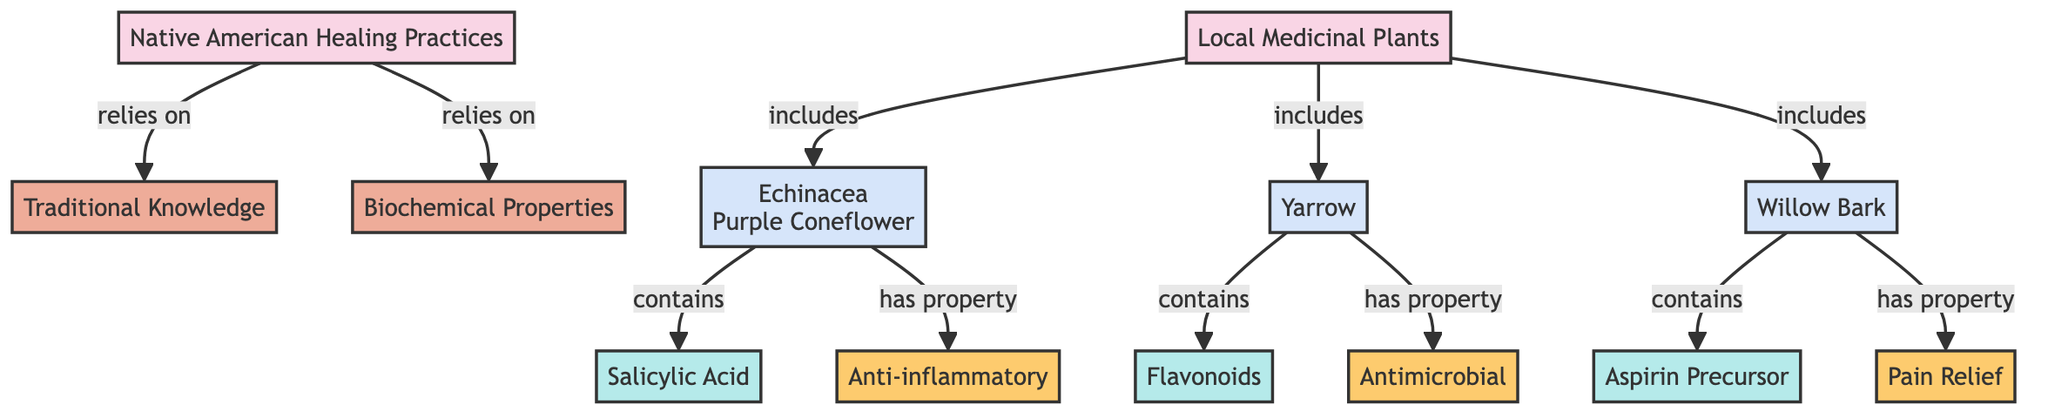What types of plants are included in local medicinal plants? The diagram lists three plants: Echinacea (Purple Coneflower), Yarrow, and Willow Bark, which fall under the category of local medicinal plants.
Answer: Echinacea, Yarrow, Willow Bark How many biochemical properties are mentioned in the diagram? The diagram presents three distinct biochemical properties: Anti-inflammatory, Antimicrobial, and Pain Relief, indicating a total of three unique properties.
Answer: 3 Which plant is associated with the property "Anti-inflammatory"? Echinacea (Purple Coneflower) is linked to the property of being anti-inflammatory, as indicated in the diagram's connections.
Answer: Echinacea (Purple Coneflower) What compound does Yarrow contain? According to the diagram, Yarrow contains Flavonoids, which are an important natural compound relevant to its healing properties.
Answer: Flavonoids What healing practice relies on traditional knowledge? The diagram indicates that Native American Healing Practices relies on traditional knowledge, signifying the importance of cultural heritage in these practices.
Answer: Traditional Knowledge What is the role of Willow Bark in local medicinal practices? Willow Bark serves as a source of Aspirin Precursor, which is vital for its application in pain relief, demonstrating its significance in traditional medicine.
Answer: Aspirin Precursor Which plant is mentioned as containing salicylic acid? The diagram specifies that Echinacea (Purple Coneflower) contains salicylic acid, highlighting its biochemical relevance in healing practices.
Answer: Salicylic Acid What relationship do Native American Healing Practices have with local medicinal plants? The diagram shows that Native American Healing Practices include local medicinal plants, which is essential for their healing methodologies and practices.
Answer: Include Which healing property is tied to Willow Bark? The healing property tied to Willow Bark, according to the diagram, is Pain Relief, linking the plant directly to its medicinal benefit.
Answer: Pain Relief How does Yarrow contribute to traditional healing? Yarrow contributes to traditional healing by having Antimicrobial properties, making it a valuable plant in Native American medicinal practices.
Answer: Antimicrobial 